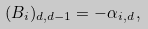<formula> <loc_0><loc_0><loc_500><loc_500>( { B } _ { i } ) _ { d , d - 1 } = - \alpha _ { i , d } \, ,</formula> 